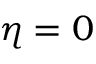Convert formula to latex. <formula><loc_0><loc_0><loc_500><loc_500>\eta = 0</formula> 